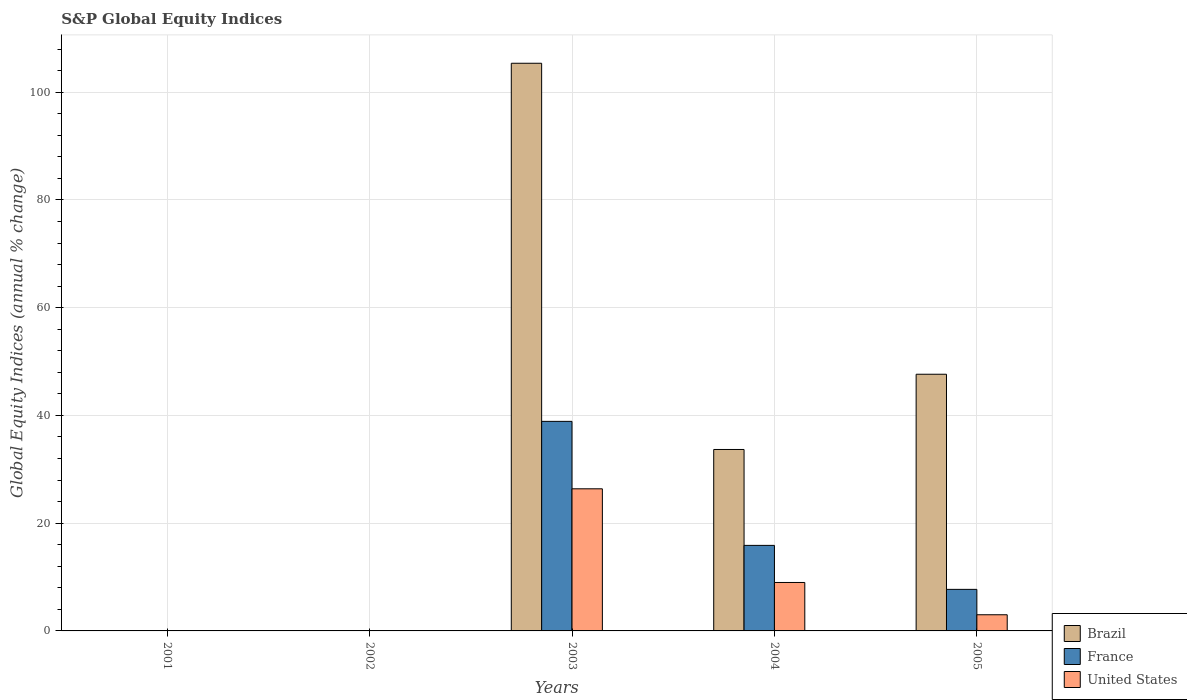Are the number of bars per tick equal to the number of legend labels?
Provide a short and direct response. No. How many bars are there on the 4th tick from the right?
Provide a succinct answer. 0. What is the label of the 4th group of bars from the left?
Offer a terse response. 2004. In how many cases, is the number of bars for a given year not equal to the number of legend labels?
Keep it short and to the point. 2. What is the global equity indices in France in 2005?
Give a very brief answer. 7.71. Across all years, what is the maximum global equity indices in France?
Your answer should be very brief. 38.9. Across all years, what is the minimum global equity indices in Brazil?
Keep it short and to the point. 0. In which year was the global equity indices in France maximum?
Your answer should be very brief. 2003. What is the total global equity indices in France in the graph?
Provide a short and direct response. 62.49. What is the difference between the global equity indices in France in 2004 and that in 2005?
Provide a succinct answer. 8.17. What is the difference between the global equity indices in Brazil in 2001 and the global equity indices in United States in 2004?
Give a very brief answer. -8.99. What is the average global equity indices in Brazil per year?
Your answer should be compact. 37.34. In the year 2003, what is the difference between the global equity indices in Brazil and global equity indices in United States?
Provide a short and direct response. 78.99. What is the ratio of the global equity indices in United States in 2004 to that in 2005?
Provide a short and direct response. 3. Is the global equity indices in United States in 2003 less than that in 2005?
Provide a succinct answer. No. Is the difference between the global equity indices in Brazil in 2003 and 2005 greater than the difference between the global equity indices in United States in 2003 and 2005?
Provide a succinct answer. Yes. What is the difference between the highest and the second highest global equity indices in France?
Your answer should be very brief. 23.02. What is the difference between the highest and the lowest global equity indices in Brazil?
Provide a succinct answer. 105.37. Is it the case that in every year, the sum of the global equity indices in Brazil and global equity indices in France is greater than the global equity indices in United States?
Offer a terse response. No. What is the difference between two consecutive major ticks on the Y-axis?
Ensure brevity in your answer.  20. Are the values on the major ticks of Y-axis written in scientific E-notation?
Make the answer very short. No. Does the graph contain any zero values?
Make the answer very short. Yes. Where does the legend appear in the graph?
Your answer should be compact. Bottom right. How many legend labels are there?
Provide a short and direct response. 3. How are the legend labels stacked?
Give a very brief answer. Vertical. What is the title of the graph?
Make the answer very short. S&P Global Equity Indices. Does "Slovak Republic" appear as one of the legend labels in the graph?
Provide a short and direct response. No. What is the label or title of the Y-axis?
Provide a succinct answer. Global Equity Indices (annual % change). What is the Global Equity Indices (annual % change) of United States in 2001?
Provide a succinct answer. 0. What is the Global Equity Indices (annual % change) in Brazil in 2002?
Provide a short and direct response. 0. What is the Global Equity Indices (annual % change) of United States in 2002?
Ensure brevity in your answer.  0. What is the Global Equity Indices (annual % change) of Brazil in 2003?
Offer a very short reply. 105.37. What is the Global Equity Indices (annual % change) of France in 2003?
Make the answer very short. 38.9. What is the Global Equity Indices (annual % change) of United States in 2003?
Your answer should be very brief. 26.38. What is the Global Equity Indices (annual % change) of Brazil in 2004?
Your response must be concise. 33.68. What is the Global Equity Indices (annual % change) of France in 2004?
Your answer should be compact. 15.88. What is the Global Equity Indices (annual % change) of United States in 2004?
Make the answer very short. 8.99. What is the Global Equity Indices (annual % change) in Brazil in 2005?
Offer a terse response. 47.64. What is the Global Equity Indices (annual % change) of France in 2005?
Provide a succinct answer. 7.71. What is the Global Equity Indices (annual % change) of United States in 2005?
Your answer should be very brief. 3. Across all years, what is the maximum Global Equity Indices (annual % change) of Brazil?
Your response must be concise. 105.37. Across all years, what is the maximum Global Equity Indices (annual % change) of France?
Make the answer very short. 38.9. Across all years, what is the maximum Global Equity Indices (annual % change) of United States?
Your answer should be compact. 26.38. Across all years, what is the minimum Global Equity Indices (annual % change) of Brazil?
Offer a very short reply. 0. Across all years, what is the minimum Global Equity Indices (annual % change) of France?
Offer a terse response. 0. Across all years, what is the minimum Global Equity Indices (annual % change) of United States?
Provide a succinct answer. 0. What is the total Global Equity Indices (annual % change) in Brazil in the graph?
Your answer should be very brief. 186.69. What is the total Global Equity Indices (annual % change) of France in the graph?
Your answer should be compact. 62.49. What is the total Global Equity Indices (annual % change) of United States in the graph?
Provide a short and direct response. 38.38. What is the difference between the Global Equity Indices (annual % change) of Brazil in 2003 and that in 2004?
Your answer should be compact. 71.69. What is the difference between the Global Equity Indices (annual % change) of France in 2003 and that in 2004?
Your answer should be compact. 23.02. What is the difference between the Global Equity Indices (annual % change) in United States in 2003 and that in 2004?
Provide a succinct answer. 17.39. What is the difference between the Global Equity Indices (annual % change) of Brazil in 2003 and that in 2005?
Your answer should be compact. 57.73. What is the difference between the Global Equity Indices (annual % change) in France in 2003 and that in 2005?
Offer a very short reply. 31.18. What is the difference between the Global Equity Indices (annual % change) of United States in 2003 and that in 2005?
Your answer should be very brief. 23.38. What is the difference between the Global Equity Indices (annual % change) in Brazil in 2004 and that in 2005?
Ensure brevity in your answer.  -13.96. What is the difference between the Global Equity Indices (annual % change) in France in 2004 and that in 2005?
Offer a very short reply. 8.17. What is the difference between the Global Equity Indices (annual % change) of United States in 2004 and that in 2005?
Your response must be concise. 5.99. What is the difference between the Global Equity Indices (annual % change) in Brazil in 2003 and the Global Equity Indices (annual % change) in France in 2004?
Offer a terse response. 89.49. What is the difference between the Global Equity Indices (annual % change) of Brazil in 2003 and the Global Equity Indices (annual % change) of United States in 2004?
Keep it short and to the point. 96.38. What is the difference between the Global Equity Indices (annual % change) of France in 2003 and the Global Equity Indices (annual % change) of United States in 2004?
Provide a succinct answer. 29.9. What is the difference between the Global Equity Indices (annual % change) of Brazil in 2003 and the Global Equity Indices (annual % change) of France in 2005?
Your answer should be compact. 97.66. What is the difference between the Global Equity Indices (annual % change) of Brazil in 2003 and the Global Equity Indices (annual % change) of United States in 2005?
Ensure brevity in your answer.  102.37. What is the difference between the Global Equity Indices (annual % change) of France in 2003 and the Global Equity Indices (annual % change) of United States in 2005?
Your answer should be compact. 35.89. What is the difference between the Global Equity Indices (annual % change) in Brazil in 2004 and the Global Equity Indices (annual % change) in France in 2005?
Give a very brief answer. 25.97. What is the difference between the Global Equity Indices (annual % change) in Brazil in 2004 and the Global Equity Indices (annual % change) in United States in 2005?
Offer a very short reply. 30.68. What is the difference between the Global Equity Indices (annual % change) of France in 2004 and the Global Equity Indices (annual % change) of United States in 2005?
Provide a succinct answer. 12.88. What is the average Global Equity Indices (annual % change) in Brazil per year?
Ensure brevity in your answer.  37.34. What is the average Global Equity Indices (annual % change) of France per year?
Make the answer very short. 12.5. What is the average Global Equity Indices (annual % change) in United States per year?
Your answer should be very brief. 7.67. In the year 2003, what is the difference between the Global Equity Indices (annual % change) of Brazil and Global Equity Indices (annual % change) of France?
Ensure brevity in your answer.  66.47. In the year 2003, what is the difference between the Global Equity Indices (annual % change) in Brazil and Global Equity Indices (annual % change) in United States?
Keep it short and to the point. 78.99. In the year 2003, what is the difference between the Global Equity Indices (annual % change) of France and Global Equity Indices (annual % change) of United States?
Your response must be concise. 12.52. In the year 2004, what is the difference between the Global Equity Indices (annual % change) in Brazil and Global Equity Indices (annual % change) in France?
Keep it short and to the point. 17.8. In the year 2004, what is the difference between the Global Equity Indices (annual % change) in Brazil and Global Equity Indices (annual % change) in United States?
Make the answer very short. 24.69. In the year 2004, what is the difference between the Global Equity Indices (annual % change) of France and Global Equity Indices (annual % change) of United States?
Offer a terse response. 6.89. In the year 2005, what is the difference between the Global Equity Indices (annual % change) of Brazil and Global Equity Indices (annual % change) of France?
Your response must be concise. 39.93. In the year 2005, what is the difference between the Global Equity Indices (annual % change) in Brazil and Global Equity Indices (annual % change) in United States?
Offer a terse response. 44.64. In the year 2005, what is the difference between the Global Equity Indices (annual % change) of France and Global Equity Indices (annual % change) of United States?
Keep it short and to the point. 4.71. What is the ratio of the Global Equity Indices (annual % change) of Brazil in 2003 to that in 2004?
Offer a very short reply. 3.13. What is the ratio of the Global Equity Indices (annual % change) of France in 2003 to that in 2004?
Keep it short and to the point. 2.45. What is the ratio of the Global Equity Indices (annual % change) of United States in 2003 to that in 2004?
Give a very brief answer. 2.93. What is the ratio of the Global Equity Indices (annual % change) in Brazil in 2003 to that in 2005?
Make the answer very short. 2.21. What is the ratio of the Global Equity Indices (annual % change) in France in 2003 to that in 2005?
Keep it short and to the point. 5.04. What is the ratio of the Global Equity Indices (annual % change) of United States in 2003 to that in 2005?
Make the answer very short. 8.79. What is the ratio of the Global Equity Indices (annual % change) in Brazil in 2004 to that in 2005?
Ensure brevity in your answer.  0.71. What is the ratio of the Global Equity Indices (annual % change) in France in 2004 to that in 2005?
Provide a short and direct response. 2.06. What is the ratio of the Global Equity Indices (annual % change) in United States in 2004 to that in 2005?
Ensure brevity in your answer.  3. What is the difference between the highest and the second highest Global Equity Indices (annual % change) in Brazil?
Make the answer very short. 57.73. What is the difference between the highest and the second highest Global Equity Indices (annual % change) of France?
Offer a very short reply. 23.02. What is the difference between the highest and the second highest Global Equity Indices (annual % change) in United States?
Your response must be concise. 17.39. What is the difference between the highest and the lowest Global Equity Indices (annual % change) in Brazil?
Ensure brevity in your answer.  105.37. What is the difference between the highest and the lowest Global Equity Indices (annual % change) of France?
Ensure brevity in your answer.  38.9. What is the difference between the highest and the lowest Global Equity Indices (annual % change) of United States?
Offer a terse response. 26.38. 